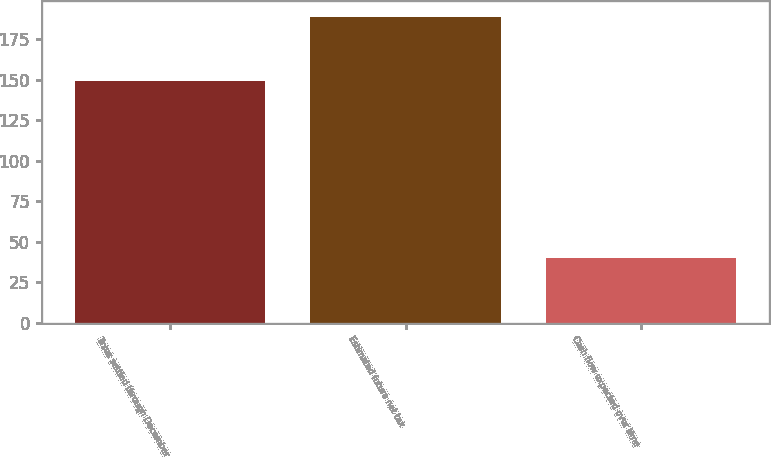Convert chart to OTSL. <chart><loc_0><loc_0><loc_500><loc_500><bar_chart><fcel>Taxes settled through December<fcel>Estimated future net tax<fcel>Cash flow expected over time<nl><fcel>149<fcel>189<fcel>40<nl></chart> 